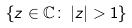<formula> <loc_0><loc_0><loc_500><loc_500>\{ z \in \mathbb { C } \colon \, | z | > 1 \}</formula> 